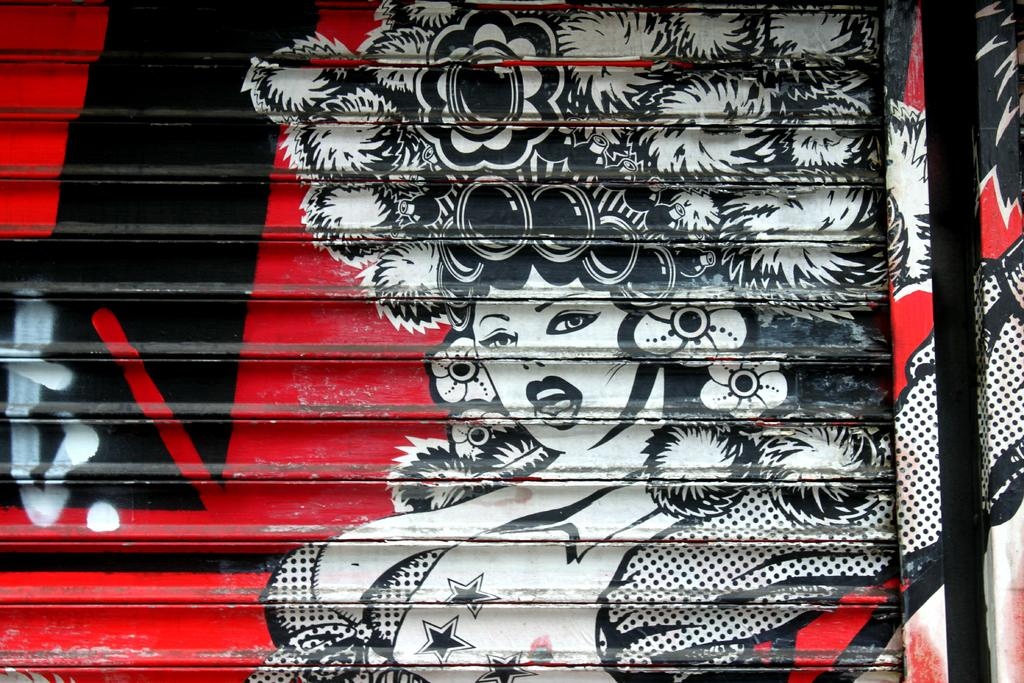What is the main object in the picture? There is a shutter in the picture. What is depicted on the shutter? There is a painting of a woman on the shutter. How many costumes does the woman in the painting wear? The woman in the painting is wearing different costumes. What colors are used for the lines beside the painting? There is a red color line and a black color line beside the painting. What type of alarm can be heard going off in the image? There is no alarm present in the image, and therefore no sound can be heard. Can you tell me how many beads are used to create the woman's necklace in the painting? The image does not provide enough detail to determine the number of beads in the woman's necklace, if any. 